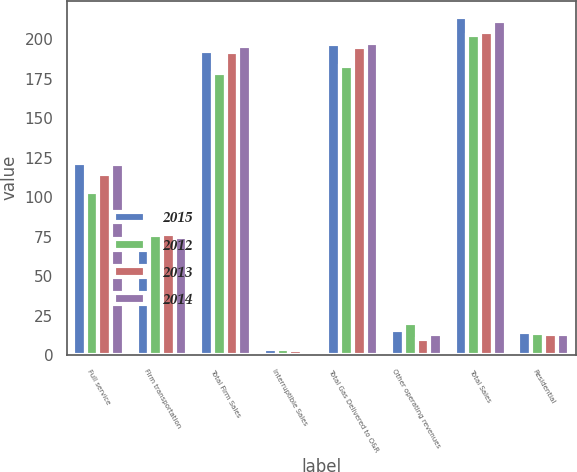Convert chart. <chart><loc_0><loc_0><loc_500><loc_500><stacked_bar_chart><ecel><fcel>Full service<fcel>Firm transportation<fcel>Total Firm Sales<fcel>Interruptible Sales<fcel>Total Gas Delivered to O&R<fcel>Other operating revenues<fcel>Total Sales<fcel>Residential<nl><fcel>2015<fcel>122<fcel>71<fcel>193<fcel>4<fcel>197<fcel>16<fcel>214<fcel>14.84<nl><fcel>2012<fcel>103<fcel>76<fcel>179<fcel>4<fcel>183<fcel>20<fcel>203<fcel>14.01<nl><fcel>2013<fcel>115<fcel>77<fcel>192<fcel>3<fcel>195<fcel>10<fcel>205<fcel>13.31<nl><fcel>2014<fcel>121<fcel>75<fcel>196<fcel>2<fcel>198<fcel>13<fcel>212<fcel>13.01<nl></chart> 